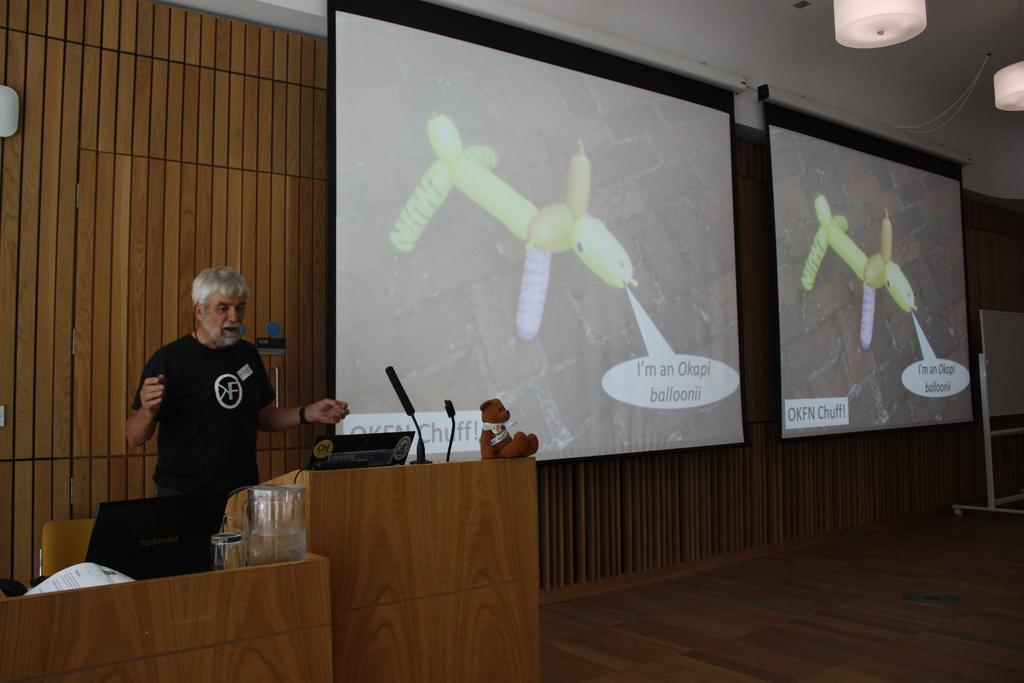What is the main subject in the image? There is a person standing in the image. What objects are present in the image that might be used for presentations? There are two podiums and two projector screens in the image. What devices are placed on the podiums? There are laptops on the podiums. What can be seen at the top of the image? There are lights visible at the top of the image. What type of lumber is being used to construct the podiums in the image? There is no information about the construction materials of the podiums in the image. How does the person in the image plan to use the boot to enhance their presentation? There is no boot present in the image, so this question cannot be answered. 